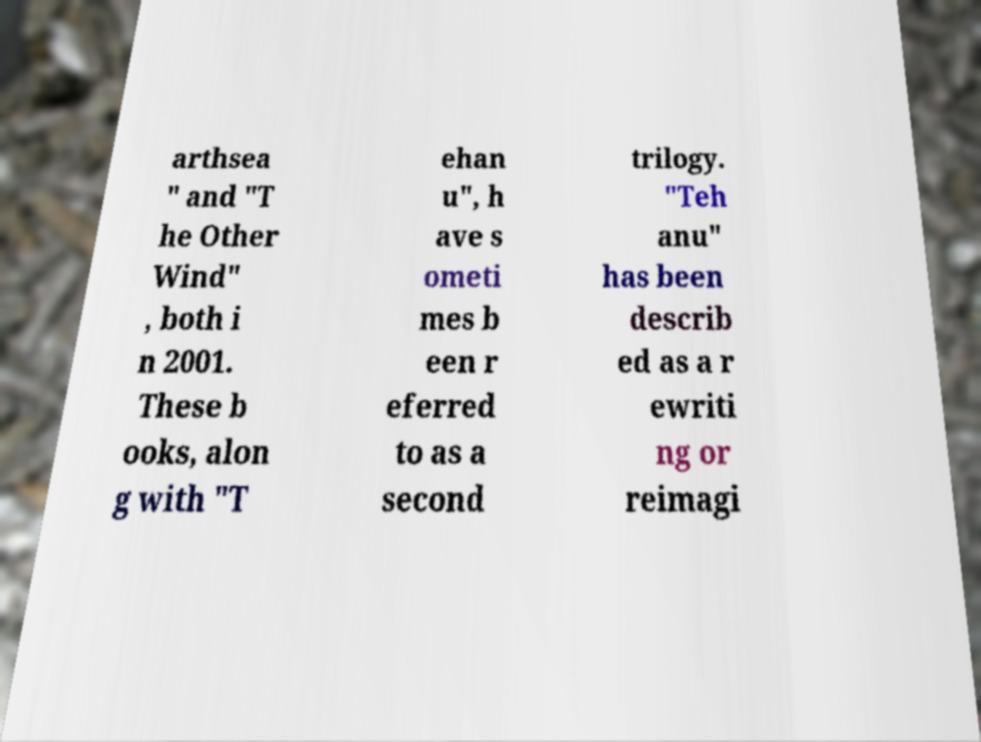Please identify and transcribe the text found in this image. arthsea " and "T he Other Wind" , both i n 2001. These b ooks, alon g with "T ehan u", h ave s ometi mes b een r eferred to as a second trilogy. "Teh anu" has been describ ed as a r ewriti ng or reimagi 